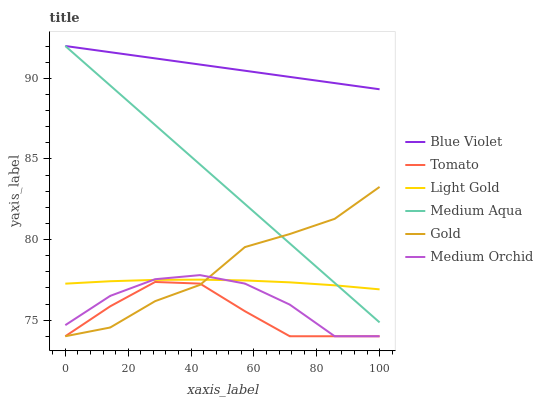Does Tomato have the minimum area under the curve?
Answer yes or no. Yes. Does Blue Violet have the maximum area under the curve?
Answer yes or no. Yes. Does Gold have the minimum area under the curve?
Answer yes or no. No. Does Gold have the maximum area under the curve?
Answer yes or no. No. Is Blue Violet the smoothest?
Answer yes or no. Yes. Is Gold the roughest?
Answer yes or no. Yes. Is Medium Orchid the smoothest?
Answer yes or no. No. Is Medium Orchid the roughest?
Answer yes or no. No. Does Tomato have the lowest value?
Answer yes or no. Yes. Does Medium Aqua have the lowest value?
Answer yes or no. No. Does Blue Violet have the highest value?
Answer yes or no. Yes. Does Gold have the highest value?
Answer yes or no. No. Is Tomato less than Blue Violet?
Answer yes or no. Yes. Is Blue Violet greater than Tomato?
Answer yes or no. Yes. Does Light Gold intersect Medium Orchid?
Answer yes or no. Yes. Is Light Gold less than Medium Orchid?
Answer yes or no. No. Is Light Gold greater than Medium Orchid?
Answer yes or no. No. Does Tomato intersect Blue Violet?
Answer yes or no. No. 